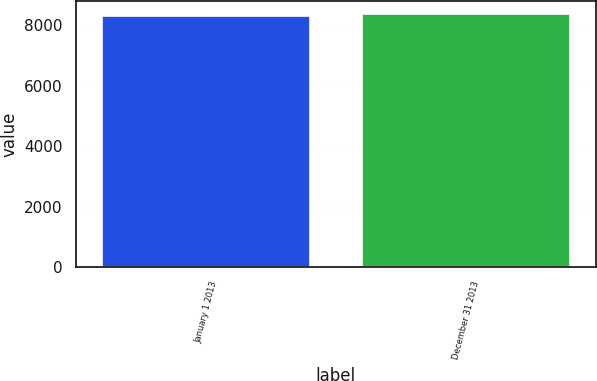Convert chart. <chart><loc_0><loc_0><loc_500><loc_500><bar_chart><fcel>January 1 2013<fcel>December 31 2013<nl><fcel>8316.8<fcel>8392.6<nl></chart> 